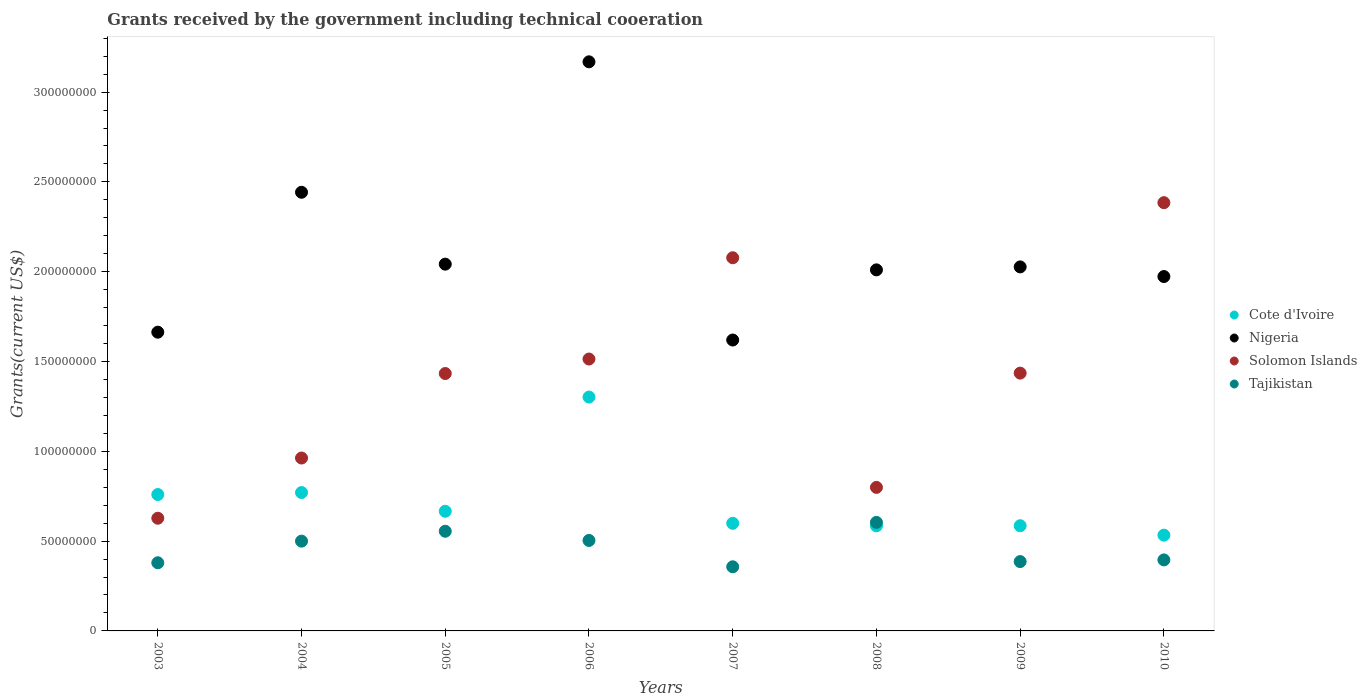How many different coloured dotlines are there?
Provide a succinct answer. 4. What is the total grants received by the government in Solomon Islands in 2006?
Provide a short and direct response. 1.51e+08. Across all years, what is the maximum total grants received by the government in Nigeria?
Your answer should be very brief. 3.17e+08. Across all years, what is the minimum total grants received by the government in Tajikistan?
Provide a succinct answer. 3.57e+07. In which year was the total grants received by the government in Cote d'Ivoire maximum?
Provide a succinct answer. 2006. In which year was the total grants received by the government in Tajikistan minimum?
Ensure brevity in your answer.  2007. What is the total total grants received by the government in Nigeria in the graph?
Offer a very short reply. 1.69e+09. What is the difference between the total grants received by the government in Cote d'Ivoire in 2005 and that in 2010?
Offer a very short reply. 1.33e+07. What is the difference between the total grants received by the government in Tajikistan in 2008 and the total grants received by the government in Cote d'Ivoire in 2010?
Offer a very short reply. 7.11e+06. What is the average total grants received by the government in Cote d'Ivoire per year?
Your answer should be compact. 7.25e+07. In the year 2006, what is the difference between the total grants received by the government in Cote d'Ivoire and total grants received by the government in Solomon Islands?
Give a very brief answer. -2.12e+07. What is the ratio of the total grants received by the government in Solomon Islands in 2006 to that in 2007?
Make the answer very short. 0.73. Is the difference between the total grants received by the government in Cote d'Ivoire in 2008 and 2010 greater than the difference between the total grants received by the government in Solomon Islands in 2008 and 2010?
Provide a succinct answer. Yes. What is the difference between the highest and the second highest total grants received by the government in Nigeria?
Your answer should be very brief. 7.26e+07. What is the difference between the highest and the lowest total grants received by the government in Cote d'Ivoire?
Provide a succinct answer. 7.69e+07. Is the sum of the total grants received by the government in Tajikistan in 2005 and 2010 greater than the maximum total grants received by the government in Nigeria across all years?
Your answer should be very brief. No. Is it the case that in every year, the sum of the total grants received by the government in Nigeria and total grants received by the government in Cote d'Ivoire  is greater than the total grants received by the government in Tajikistan?
Offer a terse response. Yes. Is the total grants received by the government in Tajikistan strictly greater than the total grants received by the government in Cote d'Ivoire over the years?
Offer a terse response. No. Is the total grants received by the government in Solomon Islands strictly less than the total grants received by the government in Cote d'Ivoire over the years?
Provide a short and direct response. No. How many dotlines are there?
Your answer should be compact. 4. Are the values on the major ticks of Y-axis written in scientific E-notation?
Give a very brief answer. No. Does the graph contain any zero values?
Provide a succinct answer. No. Does the graph contain grids?
Your response must be concise. No. How many legend labels are there?
Offer a terse response. 4. What is the title of the graph?
Offer a very short reply. Grants received by the government including technical cooeration. What is the label or title of the Y-axis?
Your answer should be very brief. Grants(current US$). What is the Grants(current US$) of Cote d'Ivoire in 2003?
Offer a very short reply. 7.59e+07. What is the Grants(current US$) of Nigeria in 2003?
Provide a short and direct response. 1.66e+08. What is the Grants(current US$) in Solomon Islands in 2003?
Make the answer very short. 6.27e+07. What is the Grants(current US$) in Tajikistan in 2003?
Offer a terse response. 3.80e+07. What is the Grants(current US$) in Cote d'Ivoire in 2004?
Provide a short and direct response. 7.70e+07. What is the Grants(current US$) in Nigeria in 2004?
Provide a succinct answer. 2.44e+08. What is the Grants(current US$) in Solomon Islands in 2004?
Keep it short and to the point. 9.63e+07. What is the Grants(current US$) in Tajikistan in 2004?
Your answer should be very brief. 5.00e+07. What is the Grants(current US$) in Cote d'Ivoire in 2005?
Give a very brief answer. 6.66e+07. What is the Grants(current US$) of Nigeria in 2005?
Make the answer very short. 2.04e+08. What is the Grants(current US$) in Solomon Islands in 2005?
Offer a terse response. 1.43e+08. What is the Grants(current US$) in Tajikistan in 2005?
Your answer should be very brief. 5.55e+07. What is the Grants(current US$) in Cote d'Ivoire in 2006?
Your answer should be very brief. 1.30e+08. What is the Grants(current US$) in Nigeria in 2006?
Make the answer very short. 3.17e+08. What is the Grants(current US$) of Solomon Islands in 2006?
Ensure brevity in your answer.  1.51e+08. What is the Grants(current US$) of Tajikistan in 2006?
Your response must be concise. 5.04e+07. What is the Grants(current US$) of Cote d'Ivoire in 2007?
Your answer should be compact. 5.99e+07. What is the Grants(current US$) in Nigeria in 2007?
Offer a terse response. 1.62e+08. What is the Grants(current US$) in Solomon Islands in 2007?
Your answer should be compact. 2.08e+08. What is the Grants(current US$) in Tajikistan in 2007?
Offer a terse response. 3.57e+07. What is the Grants(current US$) in Cote d'Ivoire in 2008?
Offer a terse response. 5.85e+07. What is the Grants(current US$) in Nigeria in 2008?
Keep it short and to the point. 2.01e+08. What is the Grants(current US$) of Solomon Islands in 2008?
Offer a terse response. 7.99e+07. What is the Grants(current US$) in Tajikistan in 2008?
Provide a succinct answer. 6.04e+07. What is the Grants(current US$) of Cote d'Ivoire in 2009?
Provide a short and direct response. 5.86e+07. What is the Grants(current US$) in Nigeria in 2009?
Offer a very short reply. 2.03e+08. What is the Grants(current US$) in Solomon Islands in 2009?
Your answer should be compact. 1.44e+08. What is the Grants(current US$) in Tajikistan in 2009?
Give a very brief answer. 3.86e+07. What is the Grants(current US$) in Cote d'Ivoire in 2010?
Offer a terse response. 5.33e+07. What is the Grants(current US$) in Nigeria in 2010?
Your answer should be compact. 1.97e+08. What is the Grants(current US$) in Solomon Islands in 2010?
Your answer should be very brief. 2.38e+08. What is the Grants(current US$) in Tajikistan in 2010?
Keep it short and to the point. 3.95e+07. Across all years, what is the maximum Grants(current US$) in Cote d'Ivoire?
Offer a very short reply. 1.30e+08. Across all years, what is the maximum Grants(current US$) in Nigeria?
Make the answer very short. 3.17e+08. Across all years, what is the maximum Grants(current US$) of Solomon Islands?
Keep it short and to the point. 2.38e+08. Across all years, what is the maximum Grants(current US$) of Tajikistan?
Provide a short and direct response. 6.04e+07. Across all years, what is the minimum Grants(current US$) of Cote d'Ivoire?
Ensure brevity in your answer.  5.33e+07. Across all years, what is the minimum Grants(current US$) in Nigeria?
Provide a succinct answer. 1.62e+08. Across all years, what is the minimum Grants(current US$) of Solomon Islands?
Give a very brief answer. 6.27e+07. Across all years, what is the minimum Grants(current US$) of Tajikistan?
Provide a short and direct response. 3.57e+07. What is the total Grants(current US$) in Cote d'Ivoire in the graph?
Your response must be concise. 5.80e+08. What is the total Grants(current US$) of Nigeria in the graph?
Provide a short and direct response. 1.69e+09. What is the total Grants(current US$) in Solomon Islands in the graph?
Your response must be concise. 1.12e+09. What is the total Grants(current US$) of Tajikistan in the graph?
Offer a terse response. 3.68e+08. What is the difference between the Grants(current US$) in Cote d'Ivoire in 2003 and that in 2004?
Provide a succinct answer. -1.10e+06. What is the difference between the Grants(current US$) in Nigeria in 2003 and that in 2004?
Your answer should be compact. -7.79e+07. What is the difference between the Grants(current US$) of Solomon Islands in 2003 and that in 2004?
Give a very brief answer. -3.35e+07. What is the difference between the Grants(current US$) of Tajikistan in 2003 and that in 2004?
Provide a short and direct response. -1.20e+07. What is the difference between the Grants(current US$) in Cote d'Ivoire in 2003 and that in 2005?
Provide a short and direct response. 9.32e+06. What is the difference between the Grants(current US$) in Nigeria in 2003 and that in 2005?
Keep it short and to the point. -3.79e+07. What is the difference between the Grants(current US$) of Solomon Islands in 2003 and that in 2005?
Make the answer very short. -8.06e+07. What is the difference between the Grants(current US$) in Tajikistan in 2003 and that in 2005?
Your answer should be very brief. -1.75e+07. What is the difference between the Grants(current US$) in Cote d'Ivoire in 2003 and that in 2006?
Offer a very short reply. -5.43e+07. What is the difference between the Grants(current US$) in Nigeria in 2003 and that in 2006?
Your answer should be very brief. -1.51e+08. What is the difference between the Grants(current US$) in Solomon Islands in 2003 and that in 2006?
Ensure brevity in your answer.  -8.86e+07. What is the difference between the Grants(current US$) of Tajikistan in 2003 and that in 2006?
Offer a terse response. -1.24e+07. What is the difference between the Grants(current US$) in Cote d'Ivoire in 2003 and that in 2007?
Offer a terse response. 1.60e+07. What is the difference between the Grants(current US$) of Nigeria in 2003 and that in 2007?
Give a very brief answer. 4.36e+06. What is the difference between the Grants(current US$) in Solomon Islands in 2003 and that in 2007?
Give a very brief answer. -1.45e+08. What is the difference between the Grants(current US$) in Tajikistan in 2003 and that in 2007?
Offer a very short reply. 2.24e+06. What is the difference between the Grants(current US$) in Cote d'Ivoire in 2003 and that in 2008?
Offer a very short reply. 1.74e+07. What is the difference between the Grants(current US$) in Nigeria in 2003 and that in 2008?
Your answer should be very brief. -3.47e+07. What is the difference between the Grants(current US$) in Solomon Islands in 2003 and that in 2008?
Make the answer very short. -1.72e+07. What is the difference between the Grants(current US$) of Tajikistan in 2003 and that in 2008?
Keep it short and to the point. -2.25e+07. What is the difference between the Grants(current US$) of Cote d'Ivoire in 2003 and that in 2009?
Provide a succinct answer. 1.74e+07. What is the difference between the Grants(current US$) of Nigeria in 2003 and that in 2009?
Make the answer very short. -3.64e+07. What is the difference between the Grants(current US$) in Solomon Islands in 2003 and that in 2009?
Your answer should be very brief. -8.08e+07. What is the difference between the Grants(current US$) in Tajikistan in 2003 and that in 2009?
Make the answer very short. -6.60e+05. What is the difference between the Grants(current US$) in Cote d'Ivoire in 2003 and that in 2010?
Provide a succinct answer. 2.26e+07. What is the difference between the Grants(current US$) in Nigeria in 2003 and that in 2010?
Offer a very short reply. -3.10e+07. What is the difference between the Grants(current US$) of Solomon Islands in 2003 and that in 2010?
Keep it short and to the point. -1.76e+08. What is the difference between the Grants(current US$) in Tajikistan in 2003 and that in 2010?
Ensure brevity in your answer.  -1.59e+06. What is the difference between the Grants(current US$) in Cote d'Ivoire in 2004 and that in 2005?
Provide a succinct answer. 1.04e+07. What is the difference between the Grants(current US$) in Nigeria in 2004 and that in 2005?
Your answer should be very brief. 4.00e+07. What is the difference between the Grants(current US$) of Solomon Islands in 2004 and that in 2005?
Your answer should be compact. -4.70e+07. What is the difference between the Grants(current US$) in Tajikistan in 2004 and that in 2005?
Make the answer very short. -5.50e+06. What is the difference between the Grants(current US$) in Cote d'Ivoire in 2004 and that in 2006?
Make the answer very short. -5.32e+07. What is the difference between the Grants(current US$) in Nigeria in 2004 and that in 2006?
Provide a short and direct response. -7.26e+07. What is the difference between the Grants(current US$) of Solomon Islands in 2004 and that in 2006?
Make the answer very short. -5.51e+07. What is the difference between the Grants(current US$) in Tajikistan in 2004 and that in 2006?
Ensure brevity in your answer.  -3.80e+05. What is the difference between the Grants(current US$) of Cote d'Ivoire in 2004 and that in 2007?
Provide a succinct answer. 1.71e+07. What is the difference between the Grants(current US$) in Nigeria in 2004 and that in 2007?
Your response must be concise. 8.23e+07. What is the difference between the Grants(current US$) of Solomon Islands in 2004 and that in 2007?
Offer a very short reply. -1.12e+08. What is the difference between the Grants(current US$) of Tajikistan in 2004 and that in 2007?
Offer a very short reply. 1.43e+07. What is the difference between the Grants(current US$) in Cote d'Ivoire in 2004 and that in 2008?
Keep it short and to the point. 1.85e+07. What is the difference between the Grants(current US$) in Nigeria in 2004 and that in 2008?
Your response must be concise. 4.32e+07. What is the difference between the Grants(current US$) of Solomon Islands in 2004 and that in 2008?
Offer a terse response. 1.63e+07. What is the difference between the Grants(current US$) of Tajikistan in 2004 and that in 2008?
Your answer should be compact. -1.04e+07. What is the difference between the Grants(current US$) of Cote d'Ivoire in 2004 and that in 2009?
Ensure brevity in your answer.  1.85e+07. What is the difference between the Grants(current US$) of Nigeria in 2004 and that in 2009?
Keep it short and to the point. 4.16e+07. What is the difference between the Grants(current US$) of Solomon Islands in 2004 and that in 2009?
Ensure brevity in your answer.  -4.73e+07. What is the difference between the Grants(current US$) in Tajikistan in 2004 and that in 2009?
Ensure brevity in your answer.  1.14e+07. What is the difference between the Grants(current US$) of Cote d'Ivoire in 2004 and that in 2010?
Provide a short and direct response. 2.37e+07. What is the difference between the Grants(current US$) in Nigeria in 2004 and that in 2010?
Give a very brief answer. 4.69e+07. What is the difference between the Grants(current US$) in Solomon Islands in 2004 and that in 2010?
Offer a very short reply. -1.42e+08. What is the difference between the Grants(current US$) of Tajikistan in 2004 and that in 2010?
Your answer should be very brief. 1.04e+07. What is the difference between the Grants(current US$) in Cote d'Ivoire in 2005 and that in 2006?
Ensure brevity in your answer.  -6.36e+07. What is the difference between the Grants(current US$) of Nigeria in 2005 and that in 2006?
Keep it short and to the point. -1.13e+08. What is the difference between the Grants(current US$) of Solomon Islands in 2005 and that in 2006?
Provide a short and direct response. -8.07e+06. What is the difference between the Grants(current US$) of Tajikistan in 2005 and that in 2006?
Your answer should be compact. 5.12e+06. What is the difference between the Grants(current US$) in Cote d'Ivoire in 2005 and that in 2007?
Offer a very short reply. 6.71e+06. What is the difference between the Grants(current US$) in Nigeria in 2005 and that in 2007?
Your answer should be very brief. 4.22e+07. What is the difference between the Grants(current US$) in Solomon Islands in 2005 and that in 2007?
Provide a short and direct response. -6.44e+07. What is the difference between the Grants(current US$) of Tajikistan in 2005 and that in 2007?
Ensure brevity in your answer.  1.98e+07. What is the difference between the Grants(current US$) in Cote d'Ivoire in 2005 and that in 2008?
Offer a very short reply. 8.12e+06. What is the difference between the Grants(current US$) in Nigeria in 2005 and that in 2008?
Ensure brevity in your answer.  3.18e+06. What is the difference between the Grants(current US$) in Solomon Islands in 2005 and that in 2008?
Your answer should be compact. 6.34e+07. What is the difference between the Grants(current US$) of Tajikistan in 2005 and that in 2008?
Give a very brief answer. -4.94e+06. What is the difference between the Grants(current US$) in Cote d'Ivoire in 2005 and that in 2009?
Give a very brief answer. 8.05e+06. What is the difference between the Grants(current US$) in Nigeria in 2005 and that in 2009?
Your response must be concise. 1.53e+06. What is the difference between the Grants(current US$) in Solomon Islands in 2005 and that in 2009?
Offer a very short reply. -2.20e+05. What is the difference between the Grants(current US$) in Tajikistan in 2005 and that in 2009?
Ensure brevity in your answer.  1.69e+07. What is the difference between the Grants(current US$) in Cote d'Ivoire in 2005 and that in 2010?
Keep it short and to the point. 1.33e+07. What is the difference between the Grants(current US$) in Nigeria in 2005 and that in 2010?
Give a very brief answer. 6.89e+06. What is the difference between the Grants(current US$) of Solomon Islands in 2005 and that in 2010?
Your answer should be compact. -9.51e+07. What is the difference between the Grants(current US$) in Tajikistan in 2005 and that in 2010?
Provide a short and direct response. 1.60e+07. What is the difference between the Grants(current US$) in Cote d'Ivoire in 2006 and that in 2007?
Offer a terse response. 7.03e+07. What is the difference between the Grants(current US$) of Nigeria in 2006 and that in 2007?
Ensure brevity in your answer.  1.55e+08. What is the difference between the Grants(current US$) of Solomon Islands in 2006 and that in 2007?
Offer a very short reply. -5.64e+07. What is the difference between the Grants(current US$) in Tajikistan in 2006 and that in 2007?
Your response must be concise. 1.47e+07. What is the difference between the Grants(current US$) of Cote d'Ivoire in 2006 and that in 2008?
Provide a succinct answer. 7.17e+07. What is the difference between the Grants(current US$) of Nigeria in 2006 and that in 2008?
Ensure brevity in your answer.  1.16e+08. What is the difference between the Grants(current US$) in Solomon Islands in 2006 and that in 2008?
Provide a short and direct response. 7.15e+07. What is the difference between the Grants(current US$) of Tajikistan in 2006 and that in 2008?
Your answer should be compact. -1.01e+07. What is the difference between the Grants(current US$) of Cote d'Ivoire in 2006 and that in 2009?
Provide a short and direct response. 7.16e+07. What is the difference between the Grants(current US$) in Nigeria in 2006 and that in 2009?
Ensure brevity in your answer.  1.14e+08. What is the difference between the Grants(current US$) of Solomon Islands in 2006 and that in 2009?
Give a very brief answer. 7.85e+06. What is the difference between the Grants(current US$) of Tajikistan in 2006 and that in 2009?
Provide a short and direct response. 1.18e+07. What is the difference between the Grants(current US$) in Cote d'Ivoire in 2006 and that in 2010?
Give a very brief answer. 7.69e+07. What is the difference between the Grants(current US$) of Nigeria in 2006 and that in 2010?
Your answer should be very brief. 1.20e+08. What is the difference between the Grants(current US$) in Solomon Islands in 2006 and that in 2010?
Offer a terse response. -8.70e+07. What is the difference between the Grants(current US$) in Tajikistan in 2006 and that in 2010?
Ensure brevity in your answer.  1.08e+07. What is the difference between the Grants(current US$) of Cote d'Ivoire in 2007 and that in 2008?
Provide a succinct answer. 1.41e+06. What is the difference between the Grants(current US$) of Nigeria in 2007 and that in 2008?
Your answer should be compact. -3.91e+07. What is the difference between the Grants(current US$) in Solomon Islands in 2007 and that in 2008?
Your response must be concise. 1.28e+08. What is the difference between the Grants(current US$) in Tajikistan in 2007 and that in 2008?
Your answer should be compact. -2.47e+07. What is the difference between the Grants(current US$) of Cote d'Ivoire in 2007 and that in 2009?
Give a very brief answer. 1.34e+06. What is the difference between the Grants(current US$) in Nigeria in 2007 and that in 2009?
Keep it short and to the point. -4.07e+07. What is the difference between the Grants(current US$) of Solomon Islands in 2007 and that in 2009?
Your response must be concise. 6.42e+07. What is the difference between the Grants(current US$) of Tajikistan in 2007 and that in 2009?
Make the answer very short. -2.90e+06. What is the difference between the Grants(current US$) in Cote d'Ivoire in 2007 and that in 2010?
Provide a short and direct response. 6.59e+06. What is the difference between the Grants(current US$) of Nigeria in 2007 and that in 2010?
Provide a short and direct response. -3.54e+07. What is the difference between the Grants(current US$) of Solomon Islands in 2007 and that in 2010?
Offer a terse response. -3.07e+07. What is the difference between the Grants(current US$) of Tajikistan in 2007 and that in 2010?
Give a very brief answer. -3.83e+06. What is the difference between the Grants(current US$) of Cote d'Ivoire in 2008 and that in 2009?
Make the answer very short. -7.00e+04. What is the difference between the Grants(current US$) in Nigeria in 2008 and that in 2009?
Give a very brief answer. -1.65e+06. What is the difference between the Grants(current US$) in Solomon Islands in 2008 and that in 2009?
Provide a short and direct response. -6.36e+07. What is the difference between the Grants(current US$) of Tajikistan in 2008 and that in 2009?
Your answer should be compact. 2.18e+07. What is the difference between the Grants(current US$) in Cote d'Ivoire in 2008 and that in 2010?
Make the answer very short. 5.18e+06. What is the difference between the Grants(current US$) of Nigeria in 2008 and that in 2010?
Offer a very short reply. 3.71e+06. What is the difference between the Grants(current US$) of Solomon Islands in 2008 and that in 2010?
Your answer should be very brief. -1.59e+08. What is the difference between the Grants(current US$) of Tajikistan in 2008 and that in 2010?
Keep it short and to the point. 2.09e+07. What is the difference between the Grants(current US$) in Cote d'Ivoire in 2009 and that in 2010?
Your answer should be compact. 5.25e+06. What is the difference between the Grants(current US$) in Nigeria in 2009 and that in 2010?
Offer a very short reply. 5.36e+06. What is the difference between the Grants(current US$) in Solomon Islands in 2009 and that in 2010?
Provide a short and direct response. -9.49e+07. What is the difference between the Grants(current US$) of Tajikistan in 2009 and that in 2010?
Make the answer very short. -9.30e+05. What is the difference between the Grants(current US$) in Cote d'Ivoire in 2003 and the Grants(current US$) in Nigeria in 2004?
Your answer should be very brief. -1.68e+08. What is the difference between the Grants(current US$) of Cote d'Ivoire in 2003 and the Grants(current US$) of Solomon Islands in 2004?
Make the answer very short. -2.03e+07. What is the difference between the Grants(current US$) of Cote d'Ivoire in 2003 and the Grants(current US$) of Tajikistan in 2004?
Offer a very short reply. 2.60e+07. What is the difference between the Grants(current US$) in Nigeria in 2003 and the Grants(current US$) in Solomon Islands in 2004?
Offer a terse response. 7.01e+07. What is the difference between the Grants(current US$) of Nigeria in 2003 and the Grants(current US$) of Tajikistan in 2004?
Give a very brief answer. 1.16e+08. What is the difference between the Grants(current US$) of Solomon Islands in 2003 and the Grants(current US$) of Tajikistan in 2004?
Provide a short and direct response. 1.28e+07. What is the difference between the Grants(current US$) of Cote d'Ivoire in 2003 and the Grants(current US$) of Nigeria in 2005?
Keep it short and to the point. -1.28e+08. What is the difference between the Grants(current US$) of Cote d'Ivoire in 2003 and the Grants(current US$) of Solomon Islands in 2005?
Give a very brief answer. -6.74e+07. What is the difference between the Grants(current US$) in Cote d'Ivoire in 2003 and the Grants(current US$) in Tajikistan in 2005?
Provide a short and direct response. 2.04e+07. What is the difference between the Grants(current US$) in Nigeria in 2003 and the Grants(current US$) in Solomon Islands in 2005?
Keep it short and to the point. 2.30e+07. What is the difference between the Grants(current US$) in Nigeria in 2003 and the Grants(current US$) in Tajikistan in 2005?
Offer a terse response. 1.11e+08. What is the difference between the Grants(current US$) of Solomon Islands in 2003 and the Grants(current US$) of Tajikistan in 2005?
Ensure brevity in your answer.  7.25e+06. What is the difference between the Grants(current US$) of Cote d'Ivoire in 2003 and the Grants(current US$) of Nigeria in 2006?
Provide a succinct answer. -2.41e+08. What is the difference between the Grants(current US$) of Cote d'Ivoire in 2003 and the Grants(current US$) of Solomon Islands in 2006?
Make the answer very short. -7.54e+07. What is the difference between the Grants(current US$) in Cote d'Ivoire in 2003 and the Grants(current US$) in Tajikistan in 2006?
Make the answer very short. 2.56e+07. What is the difference between the Grants(current US$) of Nigeria in 2003 and the Grants(current US$) of Solomon Islands in 2006?
Offer a terse response. 1.49e+07. What is the difference between the Grants(current US$) of Nigeria in 2003 and the Grants(current US$) of Tajikistan in 2006?
Your response must be concise. 1.16e+08. What is the difference between the Grants(current US$) in Solomon Islands in 2003 and the Grants(current US$) in Tajikistan in 2006?
Offer a very short reply. 1.24e+07. What is the difference between the Grants(current US$) in Cote d'Ivoire in 2003 and the Grants(current US$) in Nigeria in 2007?
Provide a succinct answer. -8.60e+07. What is the difference between the Grants(current US$) in Cote d'Ivoire in 2003 and the Grants(current US$) in Solomon Islands in 2007?
Your answer should be very brief. -1.32e+08. What is the difference between the Grants(current US$) of Cote d'Ivoire in 2003 and the Grants(current US$) of Tajikistan in 2007?
Make the answer very short. 4.02e+07. What is the difference between the Grants(current US$) in Nigeria in 2003 and the Grants(current US$) in Solomon Islands in 2007?
Your answer should be compact. -4.14e+07. What is the difference between the Grants(current US$) in Nigeria in 2003 and the Grants(current US$) in Tajikistan in 2007?
Provide a short and direct response. 1.31e+08. What is the difference between the Grants(current US$) in Solomon Islands in 2003 and the Grants(current US$) in Tajikistan in 2007?
Give a very brief answer. 2.70e+07. What is the difference between the Grants(current US$) in Cote d'Ivoire in 2003 and the Grants(current US$) in Nigeria in 2008?
Give a very brief answer. -1.25e+08. What is the difference between the Grants(current US$) in Cote d'Ivoire in 2003 and the Grants(current US$) in Solomon Islands in 2008?
Give a very brief answer. -3.98e+06. What is the difference between the Grants(current US$) in Cote d'Ivoire in 2003 and the Grants(current US$) in Tajikistan in 2008?
Make the answer very short. 1.55e+07. What is the difference between the Grants(current US$) in Nigeria in 2003 and the Grants(current US$) in Solomon Islands in 2008?
Provide a succinct answer. 8.64e+07. What is the difference between the Grants(current US$) of Nigeria in 2003 and the Grants(current US$) of Tajikistan in 2008?
Your answer should be compact. 1.06e+08. What is the difference between the Grants(current US$) in Solomon Islands in 2003 and the Grants(current US$) in Tajikistan in 2008?
Your answer should be compact. 2.31e+06. What is the difference between the Grants(current US$) of Cote d'Ivoire in 2003 and the Grants(current US$) of Nigeria in 2009?
Your answer should be compact. -1.27e+08. What is the difference between the Grants(current US$) in Cote d'Ivoire in 2003 and the Grants(current US$) in Solomon Islands in 2009?
Your answer should be compact. -6.76e+07. What is the difference between the Grants(current US$) of Cote d'Ivoire in 2003 and the Grants(current US$) of Tajikistan in 2009?
Give a very brief answer. 3.73e+07. What is the difference between the Grants(current US$) in Nigeria in 2003 and the Grants(current US$) in Solomon Islands in 2009?
Your answer should be very brief. 2.28e+07. What is the difference between the Grants(current US$) in Nigeria in 2003 and the Grants(current US$) in Tajikistan in 2009?
Offer a very short reply. 1.28e+08. What is the difference between the Grants(current US$) in Solomon Islands in 2003 and the Grants(current US$) in Tajikistan in 2009?
Your answer should be very brief. 2.41e+07. What is the difference between the Grants(current US$) in Cote d'Ivoire in 2003 and the Grants(current US$) in Nigeria in 2010?
Ensure brevity in your answer.  -1.21e+08. What is the difference between the Grants(current US$) in Cote d'Ivoire in 2003 and the Grants(current US$) in Solomon Islands in 2010?
Offer a terse response. -1.62e+08. What is the difference between the Grants(current US$) in Cote d'Ivoire in 2003 and the Grants(current US$) in Tajikistan in 2010?
Ensure brevity in your answer.  3.64e+07. What is the difference between the Grants(current US$) in Nigeria in 2003 and the Grants(current US$) in Solomon Islands in 2010?
Offer a very short reply. -7.21e+07. What is the difference between the Grants(current US$) of Nigeria in 2003 and the Grants(current US$) of Tajikistan in 2010?
Provide a succinct answer. 1.27e+08. What is the difference between the Grants(current US$) of Solomon Islands in 2003 and the Grants(current US$) of Tajikistan in 2010?
Make the answer very short. 2.32e+07. What is the difference between the Grants(current US$) of Cote d'Ivoire in 2004 and the Grants(current US$) of Nigeria in 2005?
Your answer should be very brief. -1.27e+08. What is the difference between the Grants(current US$) in Cote d'Ivoire in 2004 and the Grants(current US$) in Solomon Islands in 2005?
Provide a short and direct response. -6.63e+07. What is the difference between the Grants(current US$) in Cote d'Ivoire in 2004 and the Grants(current US$) in Tajikistan in 2005?
Ensure brevity in your answer.  2.16e+07. What is the difference between the Grants(current US$) of Nigeria in 2004 and the Grants(current US$) of Solomon Islands in 2005?
Make the answer very short. 1.01e+08. What is the difference between the Grants(current US$) of Nigeria in 2004 and the Grants(current US$) of Tajikistan in 2005?
Your answer should be compact. 1.89e+08. What is the difference between the Grants(current US$) in Solomon Islands in 2004 and the Grants(current US$) in Tajikistan in 2005?
Provide a succinct answer. 4.08e+07. What is the difference between the Grants(current US$) in Cote d'Ivoire in 2004 and the Grants(current US$) in Nigeria in 2006?
Your response must be concise. -2.40e+08. What is the difference between the Grants(current US$) in Cote d'Ivoire in 2004 and the Grants(current US$) in Solomon Islands in 2006?
Provide a short and direct response. -7.43e+07. What is the difference between the Grants(current US$) in Cote d'Ivoire in 2004 and the Grants(current US$) in Tajikistan in 2006?
Your answer should be very brief. 2.67e+07. What is the difference between the Grants(current US$) in Nigeria in 2004 and the Grants(current US$) in Solomon Islands in 2006?
Provide a succinct answer. 9.28e+07. What is the difference between the Grants(current US$) in Nigeria in 2004 and the Grants(current US$) in Tajikistan in 2006?
Your answer should be very brief. 1.94e+08. What is the difference between the Grants(current US$) in Solomon Islands in 2004 and the Grants(current US$) in Tajikistan in 2006?
Make the answer very short. 4.59e+07. What is the difference between the Grants(current US$) in Cote d'Ivoire in 2004 and the Grants(current US$) in Nigeria in 2007?
Offer a very short reply. -8.49e+07. What is the difference between the Grants(current US$) of Cote d'Ivoire in 2004 and the Grants(current US$) of Solomon Islands in 2007?
Ensure brevity in your answer.  -1.31e+08. What is the difference between the Grants(current US$) of Cote d'Ivoire in 2004 and the Grants(current US$) of Tajikistan in 2007?
Provide a short and direct response. 4.13e+07. What is the difference between the Grants(current US$) of Nigeria in 2004 and the Grants(current US$) of Solomon Islands in 2007?
Ensure brevity in your answer.  3.65e+07. What is the difference between the Grants(current US$) in Nigeria in 2004 and the Grants(current US$) in Tajikistan in 2007?
Your answer should be compact. 2.09e+08. What is the difference between the Grants(current US$) in Solomon Islands in 2004 and the Grants(current US$) in Tajikistan in 2007?
Provide a succinct answer. 6.06e+07. What is the difference between the Grants(current US$) of Cote d'Ivoire in 2004 and the Grants(current US$) of Nigeria in 2008?
Ensure brevity in your answer.  -1.24e+08. What is the difference between the Grants(current US$) of Cote d'Ivoire in 2004 and the Grants(current US$) of Solomon Islands in 2008?
Give a very brief answer. -2.88e+06. What is the difference between the Grants(current US$) of Cote d'Ivoire in 2004 and the Grants(current US$) of Tajikistan in 2008?
Ensure brevity in your answer.  1.66e+07. What is the difference between the Grants(current US$) in Nigeria in 2004 and the Grants(current US$) in Solomon Islands in 2008?
Your answer should be compact. 1.64e+08. What is the difference between the Grants(current US$) in Nigeria in 2004 and the Grants(current US$) in Tajikistan in 2008?
Your response must be concise. 1.84e+08. What is the difference between the Grants(current US$) in Solomon Islands in 2004 and the Grants(current US$) in Tajikistan in 2008?
Offer a terse response. 3.58e+07. What is the difference between the Grants(current US$) of Cote d'Ivoire in 2004 and the Grants(current US$) of Nigeria in 2009?
Give a very brief answer. -1.26e+08. What is the difference between the Grants(current US$) of Cote d'Ivoire in 2004 and the Grants(current US$) of Solomon Islands in 2009?
Make the answer very short. -6.65e+07. What is the difference between the Grants(current US$) in Cote d'Ivoire in 2004 and the Grants(current US$) in Tajikistan in 2009?
Offer a terse response. 3.84e+07. What is the difference between the Grants(current US$) of Nigeria in 2004 and the Grants(current US$) of Solomon Islands in 2009?
Give a very brief answer. 1.01e+08. What is the difference between the Grants(current US$) of Nigeria in 2004 and the Grants(current US$) of Tajikistan in 2009?
Provide a succinct answer. 2.06e+08. What is the difference between the Grants(current US$) in Solomon Islands in 2004 and the Grants(current US$) in Tajikistan in 2009?
Offer a very short reply. 5.76e+07. What is the difference between the Grants(current US$) of Cote d'Ivoire in 2004 and the Grants(current US$) of Nigeria in 2010?
Your answer should be compact. -1.20e+08. What is the difference between the Grants(current US$) of Cote d'Ivoire in 2004 and the Grants(current US$) of Solomon Islands in 2010?
Ensure brevity in your answer.  -1.61e+08. What is the difference between the Grants(current US$) of Cote d'Ivoire in 2004 and the Grants(current US$) of Tajikistan in 2010?
Make the answer very short. 3.75e+07. What is the difference between the Grants(current US$) in Nigeria in 2004 and the Grants(current US$) in Solomon Islands in 2010?
Your response must be concise. 5.79e+06. What is the difference between the Grants(current US$) of Nigeria in 2004 and the Grants(current US$) of Tajikistan in 2010?
Your answer should be compact. 2.05e+08. What is the difference between the Grants(current US$) of Solomon Islands in 2004 and the Grants(current US$) of Tajikistan in 2010?
Keep it short and to the point. 5.67e+07. What is the difference between the Grants(current US$) in Cote d'Ivoire in 2005 and the Grants(current US$) in Nigeria in 2006?
Provide a short and direct response. -2.50e+08. What is the difference between the Grants(current US$) of Cote d'Ivoire in 2005 and the Grants(current US$) of Solomon Islands in 2006?
Keep it short and to the point. -8.48e+07. What is the difference between the Grants(current US$) of Cote d'Ivoire in 2005 and the Grants(current US$) of Tajikistan in 2006?
Provide a succinct answer. 1.62e+07. What is the difference between the Grants(current US$) in Nigeria in 2005 and the Grants(current US$) in Solomon Islands in 2006?
Your answer should be very brief. 5.28e+07. What is the difference between the Grants(current US$) in Nigeria in 2005 and the Grants(current US$) in Tajikistan in 2006?
Give a very brief answer. 1.54e+08. What is the difference between the Grants(current US$) in Solomon Islands in 2005 and the Grants(current US$) in Tajikistan in 2006?
Your answer should be very brief. 9.29e+07. What is the difference between the Grants(current US$) of Cote d'Ivoire in 2005 and the Grants(current US$) of Nigeria in 2007?
Keep it short and to the point. -9.53e+07. What is the difference between the Grants(current US$) in Cote d'Ivoire in 2005 and the Grants(current US$) in Solomon Islands in 2007?
Give a very brief answer. -1.41e+08. What is the difference between the Grants(current US$) of Cote d'Ivoire in 2005 and the Grants(current US$) of Tajikistan in 2007?
Provide a short and direct response. 3.09e+07. What is the difference between the Grants(current US$) of Nigeria in 2005 and the Grants(current US$) of Solomon Islands in 2007?
Make the answer very short. -3.56e+06. What is the difference between the Grants(current US$) in Nigeria in 2005 and the Grants(current US$) in Tajikistan in 2007?
Provide a succinct answer. 1.68e+08. What is the difference between the Grants(current US$) in Solomon Islands in 2005 and the Grants(current US$) in Tajikistan in 2007?
Give a very brief answer. 1.08e+08. What is the difference between the Grants(current US$) of Cote d'Ivoire in 2005 and the Grants(current US$) of Nigeria in 2008?
Ensure brevity in your answer.  -1.34e+08. What is the difference between the Grants(current US$) in Cote d'Ivoire in 2005 and the Grants(current US$) in Solomon Islands in 2008?
Provide a short and direct response. -1.33e+07. What is the difference between the Grants(current US$) of Cote d'Ivoire in 2005 and the Grants(current US$) of Tajikistan in 2008?
Make the answer very short. 6.19e+06. What is the difference between the Grants(current US$) of Nigeria in 2005 and the Grants(current US$) of Solomon Islands in 2008?
Provide a succinct answer. 1.24e+08. What is the difference between the Grants(current US$) in Nigeria in 2005 and the Grants(current US$) in Tajikistan in 2008?
Offer a terse response. 1.44e+08. What is the difference between the Grants(current US$) of Solomon Islands in 2005 and the Grants(current US$) of Tajikistan in 2008?
Offer a very short reply. 8.29e+07. What is the difference between the Grants(current US$) of Cote d'Ivoire in 2005 and the Grants(current US$) of Nigeria in 2009?
Provide a succinct answer. -1.36e+08. What is the difference between the Grants(current US$) of Cote d'Ivoire in 2005 and the Grants(current US$) of Solomon Islands in 2009?
Your answer should be compact. -7.69e+07. What is the difference between the Grants(current US$) in Cote d'Ivoire in 2005 and the Grants(current US$) in Tajikistan in 2009?
Your answer should be compact. 2.80e+07. What is the difference between the Grants(current US$) in Nigeria in 2005 and the Grants(current US$) in Solomon Islands in 2009?
Your response must be concise. 6.07e+07. What is the difference between the Grants(current US$) in Nigeria in 2005 and the Grants(current US$) in Tajikistan in 2009?
Ensure brevity in your answer.  1.66e+08. What is the difference between the Grants(current US$) in Solomon Islands in 2005 and the Grants(current US$) in Tajikistan in 2009?
Give a very brief answer. 1.05e+08. What is the difference between the Grants(current US$) in Cote d'Ivoire in 2005 and the Grants(current US$) in Nigeria in 2010?
Your answer should be compact. -1.31e+08. What is the difference between the Grants(current US$) of Cote d'Ivoire in 2005 and the Grants(current US$) of Solomon Islands in 2010?
Provide a short and direct response. -1.72e+08. What is the difference between the Grants(current US$) in Cote d'Ivoire in 2005 and the Grants(current US$) in Tajikistan in 2010?
Your answer should be very brief. 2.71e+07. What is the difference between the Grants(current US$) of Nigeria in 2005 and the Grants(current US$) of Solomon Islands in 2010?
Give a very brief answer. -3.42e+07. What is the difference between the Grants(current US$) in Nigeria in 2005 and the Grants(current US$) in Tajikistan in 2010?
Give a very brief answer. 1.65e+08. What is the difference between the Grants(current US$) of Solomon Islands in 2005 and the Grants(current US$) of Tajikistan in 2010?
Offer a terse response. 1.04e+08. What is the difference between the Grants(current US$) of Cote d'Ivoire in 2006 and the Grants(current US$) of Nigeria in 2007?
Make the answer very short. -3.18e+07. What is the difference between the Grants(current US$) of Cote d'Ivoire in 2006 and the Grants(current US$) of Solomon Islands in 2007?
Your response must be concise. -7.76e+07. What is the difference between the Grants(current US$) in Cote d'Ivoire in 2006 and the Grants(current US$) in Tajikistan in 2007?
Your response must be concise. 9.45e+07. What is the difference between the Grants(current US$) in Nigeria in 2006 and the Grants(current US$) in Solomon Islands in 2007?
Give a very brief answer. 1.09e+08. What is the difference between the Grants(current US$) of Nigeria in 2006 and the Grants(current US$) of Tajikistan in 2007?
Make the answer very short. 2.81e+08. What is the difference between the Grants(current US$) in Solomon Islands in 2006 and the Grants(current US$) in Tajikistan in 2007?
Provide a succinct answer. 1.16e+08. What is the difference between the Grants(current US$) in Cote d'Ivoire in 2006 and the Grants(current US$) in Nigeria in 2008?
Your response must be concise. -7.08e+07. What is the difference between the Grants(current US$) of Cote d'Ivoire in 2006 and the Grants(current US$) of Solomon Islands in 2008?
Provide a short and direct response. 5.03e+07. What is the difference between the Grants(current US$) in Cote d'Ivoire in 2006 and the Grants(current US$) in Tajikistan in 2008?
Keep it short and to the point. 6.98e+07. What is the difference between the Grants(current US$) of Nigeria in 2006 and the Grants(current US$) of Solomon Islands in 2008?
Keep it short and to the point. 2.37e+08. What is the difference between the Grants(current US$) in Nigeria in 2006 and the Grants(current US$) in Tajikistan in 2008?
Your response must be concise. 2.56e+08. What is the difference between the Grants(current US$) in Solomon Islands in 2006 and the Grants(current US$) in Tajikistan in 2008?
Offer a terse response. 9.10e+07. What is the difference between the Grants(current US$) of Cote d'Ivoire in 2006 and the Grants(current US$) of Nigeria in 2009?
Ensure brevity in your answer.  -7.25e+07. What is the difference between the Grants(current US$) in Cote d'Ivoire in 2006 and the Grants(current US$) in Solomon Islands in 2009?
Your answer should be compact. -1.33e+07. What is the difference between the Grants(current US$) in Cote d'Ivoire in 2006 and the Grants(current US$) in Tajikistan in 2009?
Your response must be concise. 9.16e+07. What is the difference between the Grants(current US$) of Nigeria in 2006 and the Grants(current US$) of Solomon Islands in 2009?
Give a very brief answer. 1.73e+08. What is the difference between the Grants(current US$) in Nigeria in 2006 and the Grants(current US$) in Tajikistan in 2009?
Keep it short and to the point. 2.78e+08. What is the difference between the Grants(current US$) in Solomon Islands in 2006 and the Grants(current US$) in Tajikistan in 2009?
Your answer should be very brief. 1.13e+08. What is the difference between the Grants(current US$) in Cote d'Ivoire in 2006 and the Grants(current US$) in Nigeria in 2010?
Give a very brief answer. -6.71e+07. What is the difference between the Grants(current US$) in Cote d'Ivoire in 2006 and the Grants(current US$) in Solomon Islands in 2010?
Offer a terse response. -1.08e+08. What is the difference between the Grants(current US$) in Cote d'Ivoire in 2006 and the Grants(current US$) in Tajikistan in 2010?
Provide a short and direct response. 9.07e+07. What is the difference between the Grants(current US$) in Nigeria in 2006 and the Grants(current US$) in Solomon Islands in 2010?
Provide a short and direct response. 7.84e+07. What is the difference between the Grants(current US$) in Nigeria in 2006 and the Grants(current US$) in Tajikistan in 2010?
Provide a succinct answer. 2.77e+08. What is the difference between the Grants(current US$) in Solomon Islands in 2006 and the Grants(current US$) in Tajikistan in 2010?
Ensure brevity in your answer.  1.12e+08. What is the difference between the Grants(current US$) in Cote d'Ivoire in 2007 and the Grants(current US$) in Nigeria in 2008?
Provide a short and direct response. -1.41e+08. What is the difference between the Grants(current US$) of Cote d'Ivoire in 2007 and the Grants(current US$) of Solomon Islands in 2008?
Offer a terse response. -2.00e+07. What is the difference between the Grants(current US$) of Cote d'Ivoire in 2007 and the Grants(current US$) of Tajikistan in 2008?
Provide a short and direct response. -5.20e+05. What is the difference between the Grants(current US$) of Nigeria in 2007 and the Grants(current US$) of Solomon Islands in 2008?
Offer a very short reply. 8.20e+07. What is the difference between the Grants(current US$) of Nigeria in 2007 and the Grants(current US$) of Tajikistan in 2008?
Make the answer very short. 1.02e+08. What is the difference between the Grants(current US$) in Solomon Islands in 2007 and the Grants(current US$) in Tajikistan in 2008?
Provide a succinct answer. 1.47e+08. What is the difference between the Grants(current US$) in Cote d'Ivoire in 2007 and the Grants(current US$) in Nigeria in 2009?
Provide a short and direct response. -1.43e+08. What is the difference between the Grants(current US$) of Cote d'Ivoire in 2007 and the Grants(current US$) of Solomon Islands in 2009?
Provide a short and direct response. -8.36e+07. What is the difference between the Grants(current US$) in Cote d'Ivoire in 2007 and the Grants(current US$) in Tajikistan in 2009?
Make the answer very short. 2.13e+07. What is the difference between the Grants(current US$) of Nigeria in 2007 and the Grants(current US$) of Solomon Islands in 2009?
Give a very brief answer. 1.84e+07. What is the difference between the Grants(current US$) in Nigeria in 2007 and the Grants(current US$) in Tajikistan in 2009?
Make the answer very short. 1.23e+08. What is the difference between the Grants(current US$) of Solomon Islands in 2007 and the Grants(current US$) of Tajikistan in 2009?
Give a very brief answer. 1.69e+08. What is the difference between the Grants(current US$) of Cote d'Ivoire in 2007 and the Grants(current US$) of Nigeria in 2010?
Your answer should be very brief. -1.37e+08. What is the difference between the Grants(current US$) in Cote d'Ivoire in 2007 and the Grants(current US$) in Solomon Islands in 2010?
Offer a terse response. -1.79e+08. What is the difference between the Grants(current US$) of Cote d'Ivoire in 2007 and the Grants(current US$) of Tajikistan in 2010?
Your answer should be very brief. 2.04e+07. What is the difference between the Grants(current US$) in Nigeria in 2007 and the Grants(current US$) in Solomon Islands in 2010?
Make the answer very short. -7.65e+07. What is the difference between the Grants(current US$) in Nigeria in 2007 and the Grants(current US$) in Tajikistan in 2010?
Offer a very short reply. 1.22e+08. What is the difference between the Grants(current US$) in Solomon Islands in 2007 and the Grants(current US$) in Tajikistan in 2010?
Your answer should be very brief. 1.68e+08. What is the difference between the Grants(current US$) in Cote d'Ivoire in 2008 and the Grants(current US$) in Nigeria in 2009?
Provide a short and direct response. -1.44e+08. What is the difference between the Grants(current US$) in Cote d'Ivoire in 2008 and the Grants(current US$) in Solomon Islands in 2009?
Provide a short and direct response. -8.50e+07. What is the difference between the Grants(current US$) of Cote d'Ivoire in 2008 and the Grants(current US$) of Tajikistan in 2009?
Offer a very short reply. 1.99e+07. What is the difference between the Grants(current US$) of Nigeria in 2008 and the Grants(current US$) of Solomon Islands in 2009?
Provide a short and direct response. 5.75e+07. What is the difference between the Grants(current US$) in Nigeria in 2008 and the Grants(current US$) in Tajikistan in 2009?
Your answer should be very brief. 1.62e+08. What is the difference between the Grants(current US$) in Solomon Islands in 2008 and the Grants(current US$) in Tajikistan in 2009?
Keep it short and to the point. 4.13e+07. What is the difference between the Grants(current US$) in Cote d'Ivoire in 2008 and the Grants(current US$) in Nigeria in 2010?
Provide a succinct answer. -1.39e+08. What is the difference between the Grants(current US$) in Cote d'Ivoire in 2008 and the Grants(current US$) in Solomon Islands in 2010?
Make the answer very short. -1.80e+08. What is the difference between the Grants(current US$) in Cote d'Ivoire in 2008 and the Grants(current US$) in Tajikistan in 2010?
Your answer should be compact. 1.90e+07. What is the difference between the Grants(current US$) in Nigeria in 2008 and the Grants(current US$) in Solomon Islands in 2010?
Give a very brief answer. -3.74e+07. What is the difference between the Grants(current US$) in Nigeria in 2008 and the Grants(current US$) in Tajikistan in 2010?
Provide a succinct answer. 1.61e+08. What is the difference between the Grants(current US$) in Solomon Islands in 2008 and the Grants(current US$) in Tajikistan in 2010?
Offer a terse response. 4.04e+07. What is the difference between the Grants(current US$) in Cote d'Ivoire in 2009 and the Grants(current US$) in Nigeria in 2010?
Provide a succinct answer. -1.39e+08. What is the difference between the Grants(current US$) in Cote d'Ivoire in 2009 and the Grants(current US$) in Solomon Islands in 2010?
Your answer should be compact. -1.80e+08. What is the difference between the Grants(current US$) of Cote d'Ivoire in 2009 and the Grants(current US$) of Tajikistan in 2010?
Keep it short and to the point. 1.90e+07. What is the difference between the Grants(current US$) of Nigeria in 2009 and the Grants(current US$) of Solomon Islands in 2010?
Make the answer very short. -3.58e+07. What is the difference between the Grants(current US$) in Nigeria in 2009 and the Grants(current US$) in Tajikistan in 2010?
Provide a short and direct response. 1.63e+08. What is the difference between the Grants(current US$) of Solomon Islands in 2009 and the Grants(current US$) of Tajikistan in 2010?
Your response must be concise. 1.04e+08. What is the average Grants(current US$) in Cote d'Ivoire per year?
Make the answer very short. 7.25e+07. What is the average Grants(current US$) in Nigeria per year?
Give a very brief answer. 2.12e+08. What is the average Grants(current US$) of Solomon Islands per year?
Provide a short and direct response. 1.40e+08. What is the average Grants(current US$) in Tajikistan per year?
Give a very brief answer. 4.60e+07. In the year 2003, what is the difference between the Grants(current US$) of Cote d'Ivoire and Grants(current US$) of Nigeria?
Your answer should be very brief. -9.04e+07. In the year 2003, what is the difference between the Grants(current US$) in Cote d'Ivoire and Grants(current US$) in Solomon Islands?
Provide a succinct answer. 1.32e+07. In the year 2003, what is the difference between the Grants(current US$) in Cote d'Ivoire and Grants(current US$) in Tajikistan?
Provide a succinct answer. 3.80e+07. In the year 2003, what is the difference between the Grants(current US$) in Nigeria and Grants(current US$) in Solomon Islands?
Provide a short and direct response. 1.04e+08. In the year 2003, what is the difference between the Grants(current US$) of Nigeria and Grants(current US$) of Tajikistan?
Keep it short and to the point. 1.28e+08. In the year 2003, what is the difference between the Grants(current US$) in Solomon Islands and Grants(current US$) in Tajikistan?
Keep it short and to the point. 2.48e+07. In the year 2004, what is the difference between the Grants(current US$) of Cote d'Ivoire and Grants(current US$) of Nigeria?
Your answer should be very brief. -1.67e+08. In the year 2004, what is the difference between the Grants(current US$) in Cote d'Ivoire and Grants(current US$) in Solomon Islands?
Provide a short and direct response. -1.92e+07. In the year 2004, what is the difference between the Grants(current US$) of Cote d'Ivoire and Grants(current US$) of Tajikistan?
Make the answer very short. 2.70e+07. In the year 2004, what is the difference between the Grants(current US$) of Nigeria and Grants(current US$) of Solomon Islands?
Provide a short and direct response. 1.48e+08. In the year 2004, what is the difference between the Grants(current US$) in Nigeria and Grants(current US$) in Tajikistan?
Provide a short and direct response. 1.94e+08. In the year 2004, what is the difference between the Grants(current US$) in Solomon Islands and Grants(current US$) in Tajikistan?
Make the answer very short. 4.63e+07. In the year 2005, what is the difference between the Grants(current US$) in Cote d'Ivoire and Grants(current US$) in Nigeria?
Your response must be concise. -1.38e+08. In the year 2005, what is the difference between the Grants(current US$) in Cote d'Ivoire and Grants(current US$) in Solomon Islands?
Your answer should be compact. -7.67e+07. In the year 2005, what is the difference between the Grants(current US$) of Cote d'Ivoire and Grants(current US$) of Tajikistan?
Your response must be concise. 1.11e+07. In the year 2005, what is the difference between the Grants(current US$) of Nigeria and Grants(current US$) of Solomon Islands?
Keep it short and to the point. 6.09e+07. In the year 2005, what is the difference between the Grants(current US$) in Nigeria and Grants(current US$) in Tajikistan?
Keep it short and to the point. 1.49e+08. In the year 2005, what is the difference between the Grants(current US$) of Solomon Islands and Grants(current US$) of Tajikistan?
Your answer should be compact. 8.78e+07. In the year 2006, what is the difference between the Grants(current US$) of Cote d'Ivoire and Grants(current US$) of Nigeria?
Your answer should be very brief. -1.87e+08. In the year 2006, what is the difference between the Grants(current US$) of Cote d'Ivoire and Grants(current US$) of Solomon Islands?
Make the answer very short. -2.12e+07. In the year 2006, what is the difference between the Grants(current US$) of Cote d'Ivoire and Grants(current US$) of Tajikistan?
Your answer should be compact. 7.98e+07. In the year 2006, what is the difference between the Grants(current US$) of Nigeria and Grants(current US$) of Solomon Islands?
Keep it short and to the point. 1.65e+08. In the year 2006, what is the difference between the Grants(current US$) in Nigeria and Grants(current US$) in Tajikistan?
Keep it short and to the point. 2.66e+08. In the year 2006, what is the difference between the Grants(current US$) of Solomon Islands and Grants(current US$) of Tajikistan?
Make the answer very short. 1.01e+08. In the year 2007, what is the difference between the Grants(current US$) in Cote d'Ivoire and Grants(current US$) in Nigeria?
Offer a very short reply. -1.02e+08. In the year 2007, what is the difference between the Grants(current US$) in Cote d'Ivoire and Grants(current US$) in Solomon Islands?
Offer a terse response. -1.48e+08. In the year 2007, what is the difference between the Grants(current US$) in Cote d'Ivoire and Grants(current US$) in Tajikistan?
Your answer should be very brief. 2.42e+07. In the year 2007, what is the difference between the Grants(current US$) in Nigeria and Grants(current US$) in Solomon Islands?
Your response must be concise. -4.58e+07. In the year 2007, what is the difference between the Grants(current US$) of Nigeria and Grants(current US$) of Tajikistan?
Ensure brevity in your answer.  1.26e+08. In the year 2007, what is the difference between the Grants(current US$) of Solomon Islands and Grants(current US$) of Tajikistan?
Your response must be concise. 1.72e+08. In the year 2008, what is the difference between the Grants(current US$) in Cote d'Ivoire and Grants(current US$) in Nigeria?
Give a very brief answer. -1.43e+08. In the year 2008, what is the difference between the Grants(current US$) of Cote d'Ivoire and Grants(current US$) of Solomon Islands?
Ensure brevity in your answer.  -2.14e+07. In the year 2008, what is the difference between the Grants(current US$) in Cote d'Ivoire and Grants(current US$) in Tajikistan?
Give a very brief answer. -1.93e+06. In the year 2008, what is the difference between the Grants(current US$) in Nigeria and Grants(current US$) in Solomon Islands?
Provide a short and direct response. 1.21e+08. In the year 2008, what is the difference between the Grants(current US$) of Nigeria and Grants(current US$) of Tajikistan?
Ensure brevity in your answer.  1.41e+08. In the year 2008, what is the difference between the Grants(current US$) of Solomon Islands and Grants(current US$) of Tajikistan?
Offer a terse response. 1.95e+07. In the year 2009, what is the difference between the Grants(current US$) in Cote d'Ivoire and Grants(current US$) in Nigeria?
Your response must be concise. -1.44e+08. In the year 2009, what is the difference between the Grants(current US$) of Cote d'Ivoire and Grants(current US$) of Solomon Islands?
Offer a terse response. -8.50e+07. In the year 2009, what is the difference between the Grants(current US$) of Cote d'Ivoire and Grants(current US$) of Tajikistan?
Ensure brevity in your answer.  2.00e+07. In the year 2009, what is the difference between the Grants(current US$) in Nigeria and Grants(current US$) in Solomon Islands?
Offer a terse response. 5.91e+07. In the year 2009, what is the difference between the Grants(current US$) of Nigeria and Grants(current US$) of Tajikistan?
Your answer should be compact. 1.64e+08. In the year 2009, what is the difference between the Grants(current US$) of Solomon Islands and Grants(current US$) of Tajikistan?
Your answer should be very brief. 1.05e+08. In the year 2010, what is the difference between the Grants(current US$) in Cote d'Ivoire and Grants(current US$) in Nigeria?
Your answer should be very brief. -1.44e+08. In the year 2010, what is the difference between the Grants(current US$) in Cote d'Ivoire and Grants(current US$) in Solomon Islands?
Ensure brevity in your answer.  -1.85e+08. In the year 2010, what is the difference between the Grants(current US$) in Cote d'Ivoire and Grants(current US$) in Tajikistan?
Your response must be concise. 1.38e+07. In the year 2010, what is the difference between the Grants(current US$) in Nigeria and Grants(current US$) in Solomon Islands?
Give a very brief answer. -4.11e+07. In the year 2010, what is the difference between the Grants(current US$) in Nigeria and Grants(current US$) in Tajikistan?
Offer a very short reply. 1.58e+08. In the year 2010, what is the difference between the Grants(current US$) of Solomon Islands and Grants(current US$) of Tajikistan?
Ensure brevity in your answer.  1.99e+08. What is the ratio of the Grants(current US$) in Cote d'Ivoire in 2003 to that in 2004?
Give a very brief answer. 0.99. What is the ratio of the Grants(current US$) in Nigeria in 2003 to that in 2004?
Keep it short and to the point. 0.68. What is the ratio of the Grants(current US$) of Solomon Islands in 2003 to that in 2004?
Your answer should be compact. 0.65. What is the ratio of the Grants(current US$) in Tajikistan in 2003 to that in 2004?
Provide a succinct answer. 0.76. What is the ratio of the Grants(current US$) in Cote d'Ivoire in 2003 to that in 2005?
Ensure brevity in your answer.  1.14. What is the ratio of the Grants(current US$) of Nigeria in 2003 to that in 2005?
Provide a succinct answer. 0.81. What is the ratio of the Grants(current US$) of Solomon Islands in 2003 to that in 2005?
Give a very brief answer. 0.44. What is the ratio of the Grants(current US$) of Tajikistan in 2003 to that in 2005?
Your answer should be compact. 0.68. What is the ratio of the Grants(current US$) in Cote d'Ivoire in 2003 to that in 2006?
Your answer should be compact. 0.58. What is the ratio of the Grants(current US$) of Nigeria in 2003 to that in 2006?
Your response must be concise. 0.52. What is the ratio of the Grants(current US$) in Solomon Islands in 2003 to that in 2006?
Provide a short and direct response. 0.41. What is the ratio of the Grants(current US$) in Tajikistan in 2003 to that in 2006?
Keep it short and to the point. 0.75. What is the ratio of the Grants(current US$) of Cote d'Ivoire in 2003 to that in 2007?
Provide a short and direct response. 1.27. What is the ratio of the Grants(current US$) of Nigeria in 2003 to that in 2007?
Your answer should be compact. 1.03. What is the ratio of the Grants(current US$) of Solomon Islands in 2003 to that in 2007?
Ensure brevity in your answer.  0.3. What is the ratio of the Grants(current US$) of Tajikistan in 2003 to that in 2007?
Offer a terse response. 1.06. What is the ratio of the Grants(current US$) in Cote d'Ivoire in 2003 to that in 2008?
Give a very brief answer. 1.3. What is the ratio of the Grants(current US$) of Nigeria in 2003 to that in 2008?
Ensure brevity in your answer.  0.83. What is the ratio of the Grants(current US$) in Solomon Islands in 2003 to that in 2008?
Your answer should be very brief. 0.79. What is the ratio of the Grants(current US$) of Tajikistan in 2003 to that in 2008?
Keep it short and to the point. 0.63. What is the ratio of the Grants(current US$) of Cote d'Ivoire in 2003 to that in 2009?
Provide a succinct answer. 1.3. What is the ratio of the Grants(current US$) in Nigeria in 2003 to that in 2009?
Your response must be concise. 0.82. What is the ratio of the Grants(current US$) of Solomon Islands in 2003 to that in 2009?
Provide a short and direct response. 0.44. What is the ratio of the Grants(current US$) of Tajikistan in 2003 to that in 2009?
Your answer should be very brief. 0.98. What is the ratio of the Grants(current US$) of Cote d'Ivoire in 2003 to that in 2010?
Provide a succinct answer. 1.42. What is the ratio of the Grants(current US$) of Nigeria in 2003 to that in 2010?
Ensure brevity in your answer.  0.84. What is the ratio of the Grants(current US$) of Solomon Islands in 2003 to that in 2010?
Provide a succinct answer. 0.26. What is the ratio of the Grants(current US$) in Tajikistan in 2003 to that in 2010?
Provide a short and direct response. 0.96. What is the ratio of the Grants(current US$) in Cote d'Ivoire in 2004 to that in 2005?
Provide a short and direct response. 1.16. What is the ratio of the Grants(current US$) in Nigeria in 2004 to that in 2005?
Offer a terse response. 1.2. What is the ratio of the Grants(current US$) of Solomon Islands in 2004 to that in 2005?
Your answer should be compact. 0.67. What is the ratio of the Grants(current US$) of Tajikistan in 2004 to that in 2005?
Your answer should be very brief. 0.9. What is the ratio of the Grants(current US$) in Cote d'Ivoire in 2004 to that in 2006?
Keep it short and to the point. 0.59. What is the ratio of the Grants(current US$) in Nigeria in 2004 to that in 2006?
Provide a short and direct response. 0.77. What is the ratio of the Grants(current US$) of Solomon Islands in 2004 to that in 2006?
Ensure brevity in your answer.  0.64. What is the ratio of the Grants(current US$) in Cote d'Ivoire in 2004 to that in 2007?
Offer a terse response. 1.29. What is the ratio of the Grants(current US$) of Nigeria in 2004 to that in 2007?
Your answer should be compact. 1.51. What is the ratio of the Grants(current US$) of Solomon Islands in 2004 to that in 2007?
Make the answer very short. 0.46. What is the ratio of the Grants(current US$) of Tajikistan in 2004 to that in 2007?
Your answer should be compact. 1.4. What is the ratio of the Grants(current US$) of Cote d'Ivoire in 2004 to that in 2008?
Provide a short and direct response. 1.32. What is the ratio of the Grants(current US$) in Nigeria in 2004 to that in 2008?
Your response must be concise. 1.21. What is the ratio of the Grants(current US$) in Solomon Islands in 2004 to that in 2008?
Make the answer very short. 1.2. What is the ratio of the Grants(current US$) of Tajikistan in 2004 to that in 2008?
Offer a terse response. 0.83. What is the ratio of the Grants(current US$) of Cote d'Ivoire in 2004 to that in 2009?
Your answer should be very brief. 1.32. What is the ratio of the Grants(current US$) in Nigeria in 2004 to that in 2009?
Your response must be concise. 1.21. What is the ratio of the Grants(current US$) of Solomon Islands in 2004 to that in 2009?
Provide a succinct answer. 0.67. What is the ratio of the Grants(current US$) of Tajikistan in 2004 to that in 2009?
Your answer should be very brief. 1.29. What is the ratio of the Grants(current US$) in Cote d'Ivoire in 2004 to that in 2010?
Offer a very short reply. 1.44. What is the ratio of the Grants(current US$) in Nigeria in 2004 to that in 2010?
Your response must be concise. 1.24. What is the ratio of the Grants(current US$) of Solomon Islands in 2004 to that in 2010?
Keep it short and to the point. 0.4. What is the ratio of the Grants(current US$) of Tajikistan in 2004 to that in 2010?
Offer a very short reply. 1.26. What is the ratio of the Grants(current US$) in Cote d'Ivoire in 2005 to that in 2006?
Provide a succinct answer. 0.51. What is the ratio of the Grants(current US$) in Nigeria in 2005 to that in 2006?
Ensure brevity in your answer.  0.64. What is the ratio of the Grants(current US$) in Solomon Islands in 2005 to that in 2006?
Keep it short and to the point. 0.95. What is the ratio of the Grants(current US$) in Tajikistan in 2005 to that in 2006?
Provide a short and direct response. 1.1. What is the ratio of the Grants(current US$) of Cote d'Ivoire in 2005 to that in 2007?
Your response must be concise. 1.11. What is the ratio of the Grants(current US$) of Nigeria in 2005 to that in 2007?
Offer a very short reply. 1.26. What is the ratio of the Grants(current US$) of Solomon Islands in 2005 to that in 2007?
Make the answer very short. 0.69. What is the ratio of the Grants(current US$) in Tajikistan in 2005 to that in 2007?
Make the answer very short. 1.55. What is the ratio of the Grants(current US$) of Cote d'Ivoire in 2005 to that in 2008?
Keep it short and to the point. 1.14. What is the ratio of the Grants(current US$) in Nigeria in 2005 to that in 2008?
Keep it short and to the point. 1.02. What is the ratio of the Grants(current US$) of Solomon Islands in 2005 to that in 2008?
Your answer should be compact. 1.79. What is the ratio of the Grants(current US$) of Tajikistan in 2005 to that in 2008?
Your answer should be very brief. 0.92. What is the ratio of the Grants(current US$) of Cote d'Ivoire in 2005 to that in 2009?
Give a very brief answer. 1.14. What is the ratio of the Grants(current US$) of Nigeria in 2005 to that in 2009?
Keep it short and to the point. 1.01. What is the ratio of the Grants(current US$) of Tajikistan in 2005 to that in 2009?
Provide a succinct answer. 1.44. What is the ratio of the Grants(current US$) in Cote d'Ivoire in 2005 to that in 2010?
Provide a succinct answer. 1.25. What is the ratio of the Grants(current US$) in Nigeria in 2005 to that in 2010?
Your response must be concise. 1.03. What is the ratio of the Grants(current US$) of Solomon Islands in 2005 to that in 2010?
Provide a succinct answer. 0.6. What is the ratio of the Grants(current US$) of Tajikistan in 2005 to that in 2010?
Your response must be concise. 1.4. What is the ratio of the Grants(current US$) in Cote d'Ivoire in 2006 to that in 2007?
Offer a very short reply. 2.17. What is the ratio of the Grants(current US$) in Nigeria in 2006 to that in 2007?
Your response must be concise. 1.96. What is the ratio of the Grants(current US$) in Solomon Islands in 2006 to that in 2007?
Your answer should be very brief. 0.73. What is the ratio of the Grants(current US$) of Tajikistan in 2006 to that in 2007?
Ensure brevity in your answer.  1.41. What is the ratio of the Grants(current US$) in Cote d'Ivoire in 2006 to that in 2008?
Give a very brief answer. 2.23. What is the ratio of the Grants(current US$) in Nigeria in 2006 to that in 2008?
Your answer should be compact. 1.58. What is the ratio of the Grants(current US$) in Solomon Islands in 2006 to that in 2008?
Give a very brief answer. 1.89. What is the ratio of the Grants(current US$) in Tajikistan in 2006 to that in 2008?
Your response must be concise. 0.83. What is the ratio of the Grants(current US$) of Cote d'Ivoire in 2006 to that in 2009?
Ensure brevity in your answer.  2.22. What is the ratio of the Grants(current US$) of Nigeria in 2006 to that in 2009?
Your answer should be very brief. 1.56. What is the ratio of the Grants(current US$) of Solomon Islands in 2006 to that in 2009?
Ensure brevity in your answer.  1.05. What is the ratio of the Grants(current US$) of Tajikistan in 2006 to that in 2009?
Ensure brevity in your answer.  1.3. What is the ratio of the Grants(current US$) in Cote d'Ivoire in 2006 to that in 2010?
Ensure brevity in your answer.  2.44. What is the ratio of the Grants(current US$) of Nigeria in 2006 to that in 2010?
Keep it short and to the point. 1.61. What is the ratio of the Grants(current US$) in Solomon Islands in 2006 to that in 2010?
Your answer should be very brief. 0.63. What is the ratio of the Grants(current US$) of Tajikistan in 2006 to that in 2010?
Your response must be concise. 1.27. What is the ratio of the Grants(current US$) in Cote d'Ivoire in 2007 to that in 2008?
Your answer should be very brief. 1.02. What is the ratio of the Grants(current US$) of Nigeria in 2007 to that in 2008?
Offer a terse response. 0.81. What is the ratio of the Grants(current US$) in Solomon Islands in 2007 to that in 2008?
Offer a terse response. 2.6. What is the ratio of the Grants(current US$) of Tajikistan in 2007 to that in 2008?
Your response must be concise. 0.59. What is the ratio of the Grants(current US$) in Cote d'Ivoire in 2007 to that in 2009?
Keep it short and to the point. 1.02. What is the ratio of the Grants(current US$) in Nigeria in 2007 to that in 2009?
Ensure brevity in your answer.  0.8. What is the ratio of the Grants(current US$) in Solomon Islands in 2007 to that in 2009?
Provide a short and direct response. 1.45. What is the ratio of the Grants(current US$) in Tajikistan in 2007 to that in 2009?
Your response must be concise. 0.92. What is the ratio of the Grants(current US$) in Cote d'Ivoire in 2007 to that in 2010?
Give a very brief answer. 1.12. What is the ratio of the Grants(current US$) of Nigeria in 2007 to that in 2010?
Keep it short and to the point. 0.82. What is the ratio of the Grants(current US$) of Solomon Islands in 2007 to that in 2010?
Give a very brief answer. 0.87. What is the ratio of the Grants(current US$) in Tajikistan in 2007 to that in 2010?
Give a very brief answer. 0.9. What is the ratio of the Grants(current US$) of Cote d'Ivoire in 2008 to that in 2009?
Provide a succinct answer. 1. What is the ratio of the Grants(current US$) in Nigeria in 2008 to that in 2009?
Offer a very short reply. 0.99. What is the ratio of the Grants(current US$) of Solomon Islands in 2008 to that in 2009?
Provide a short and direct response. 0.56. What is the ratio of the Grants(current US$) of Tajikistan in 2008 to that in 2009?
Your response must be concise. 1.57. What is the ratio of the Grants(current US$) of Cote d'Ivoire in 2008 to that in 2010?
Make the answer very short. 1.1. What is the ratio of the Grants(current US$) in Nigeria in 2008 to that in 2010?
Your answer should be compact. 1.02. What is the ratio of the Grants(current US$) in Solomon Islands in 2008 to that in 2010?
Give a very brief answer. 0.34. What is the ratio of the Grants(current US$) in Tajikistan in 2008 to that in 2010?
Offer a terse response. 1.53. What is the ratio of the Grants(current US$) in Cote d'Ivoire in 2009 to that in 2010?
Make the answer very short. 1.1. What is the ratio of the Grants(current US$) in Nigeria in 2009 to that in 2010?
Keep it short and to the point. 1.03. What is the ratio of the Grants(current US$) of Solomon Islands in 2009 to that in 2010?
Give a very brief answer. 0.6. What is the ratio of the Grants(current US$) of Tajikistan in 2009 to that in 2010?
Provide a short and direct response. 0.98. What is the difference between the highest and the second highest Grants(current US$) of Cote d'Ivoire?
Keep it short and to the point. 5.32e+07. What is the difference between the highest and the second highest Grants(current US$) in Nigeria?
Your answer should be compact. 7.26e+07. What is the difference between the highest and the second highest Grants(current US$) in Solomon Islands?
Make the answer very short. 3.07e+07. What is the difference between the highest and the second highest Grants(current US$) of Tajikistan?
Give a very brief answer. 4.94e+06. What is the difference between the highest and the lowest Grants(current US$) of Cote d'Ivoire?
Provide a short and direct response. 7.69e+07. What is the difference between the highest and the lowest Grants(current US$) of Nigeria?
Your response must be concise. 1.55e+08. What is the difference between the highest and the lowest Grants(current US$) in Solomon Islands?
Offer a terse response. 1.76e+08. What is the difference between the highest and the lowest Grants(current US$) of Tajikistan?
Your answer should be compact. 2.47e+07. 